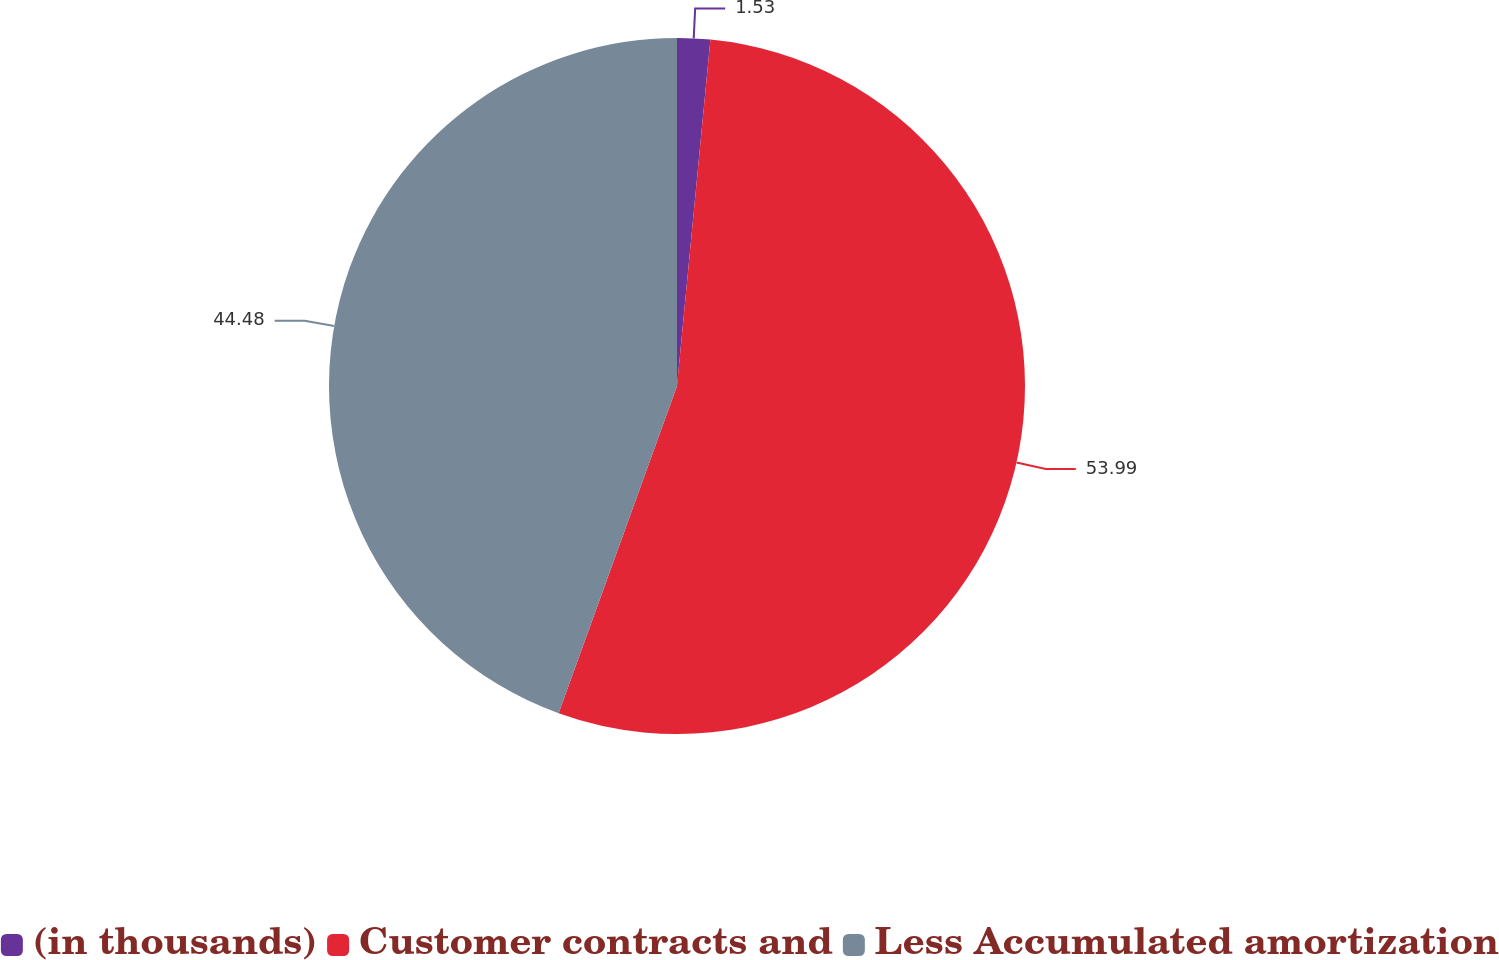<chart> <loc_0><loc_0><loc_500><loc_500><pie_chart><fcel>(in thousands)<fcel>Customer contracts and<fcel>Less Accumulated amortization<nl><fcel>1.53%<fcel>54.0%<fcel>44.48%<nl></chart> 